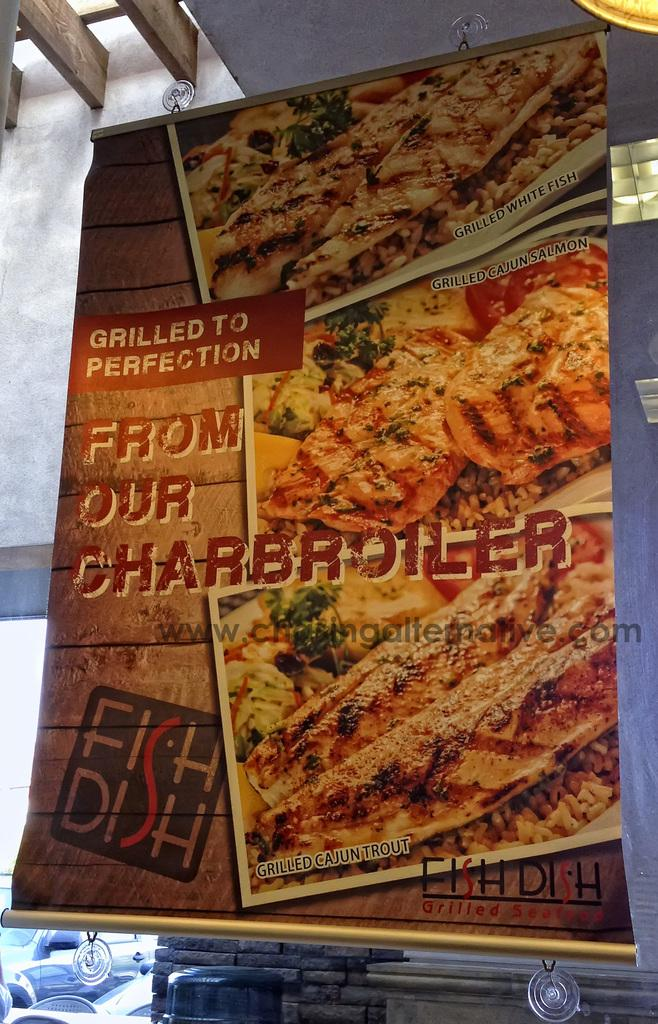What is the main object in the image? There is a banner in the image. What colors are used on the banner? The banner is orange, brown, and black in color. Where is the banner hung? The banner is hanged on a white surface. What can be seen in the background of the image? There is a wall visible in the background of the image, along with other objects. Can you read the note that is running across the banner in the image? There is no note visible on the banner in the image, and the banner is not moving or running. 